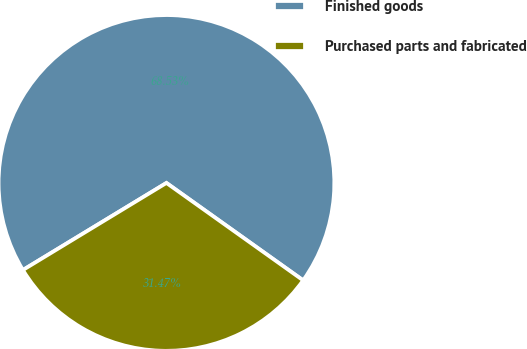<chart> <loc_0><loc_0><loc_500><loc_500><pie_chart><fcel>Finished goods<fcel>Purchased parts and fabricated<nl><fcel>68.53%<fcel>31.47%<nl></chart> 